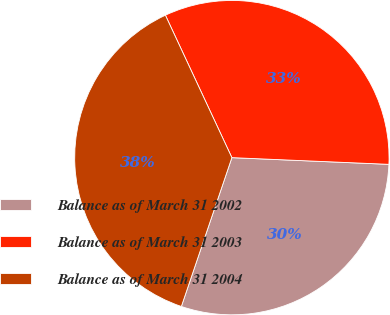Convert chart. <chart><loc_0><loc_0><loc_500><loc_500><pie_chart><fcel>Balance as of March 31 2002<fcel>Balance as of March 31 2003<fcel>Balance as of March 31 2004<nl><fcel>29.53%<fcel>32.63%<fcel>37.84%<nl></chart> 